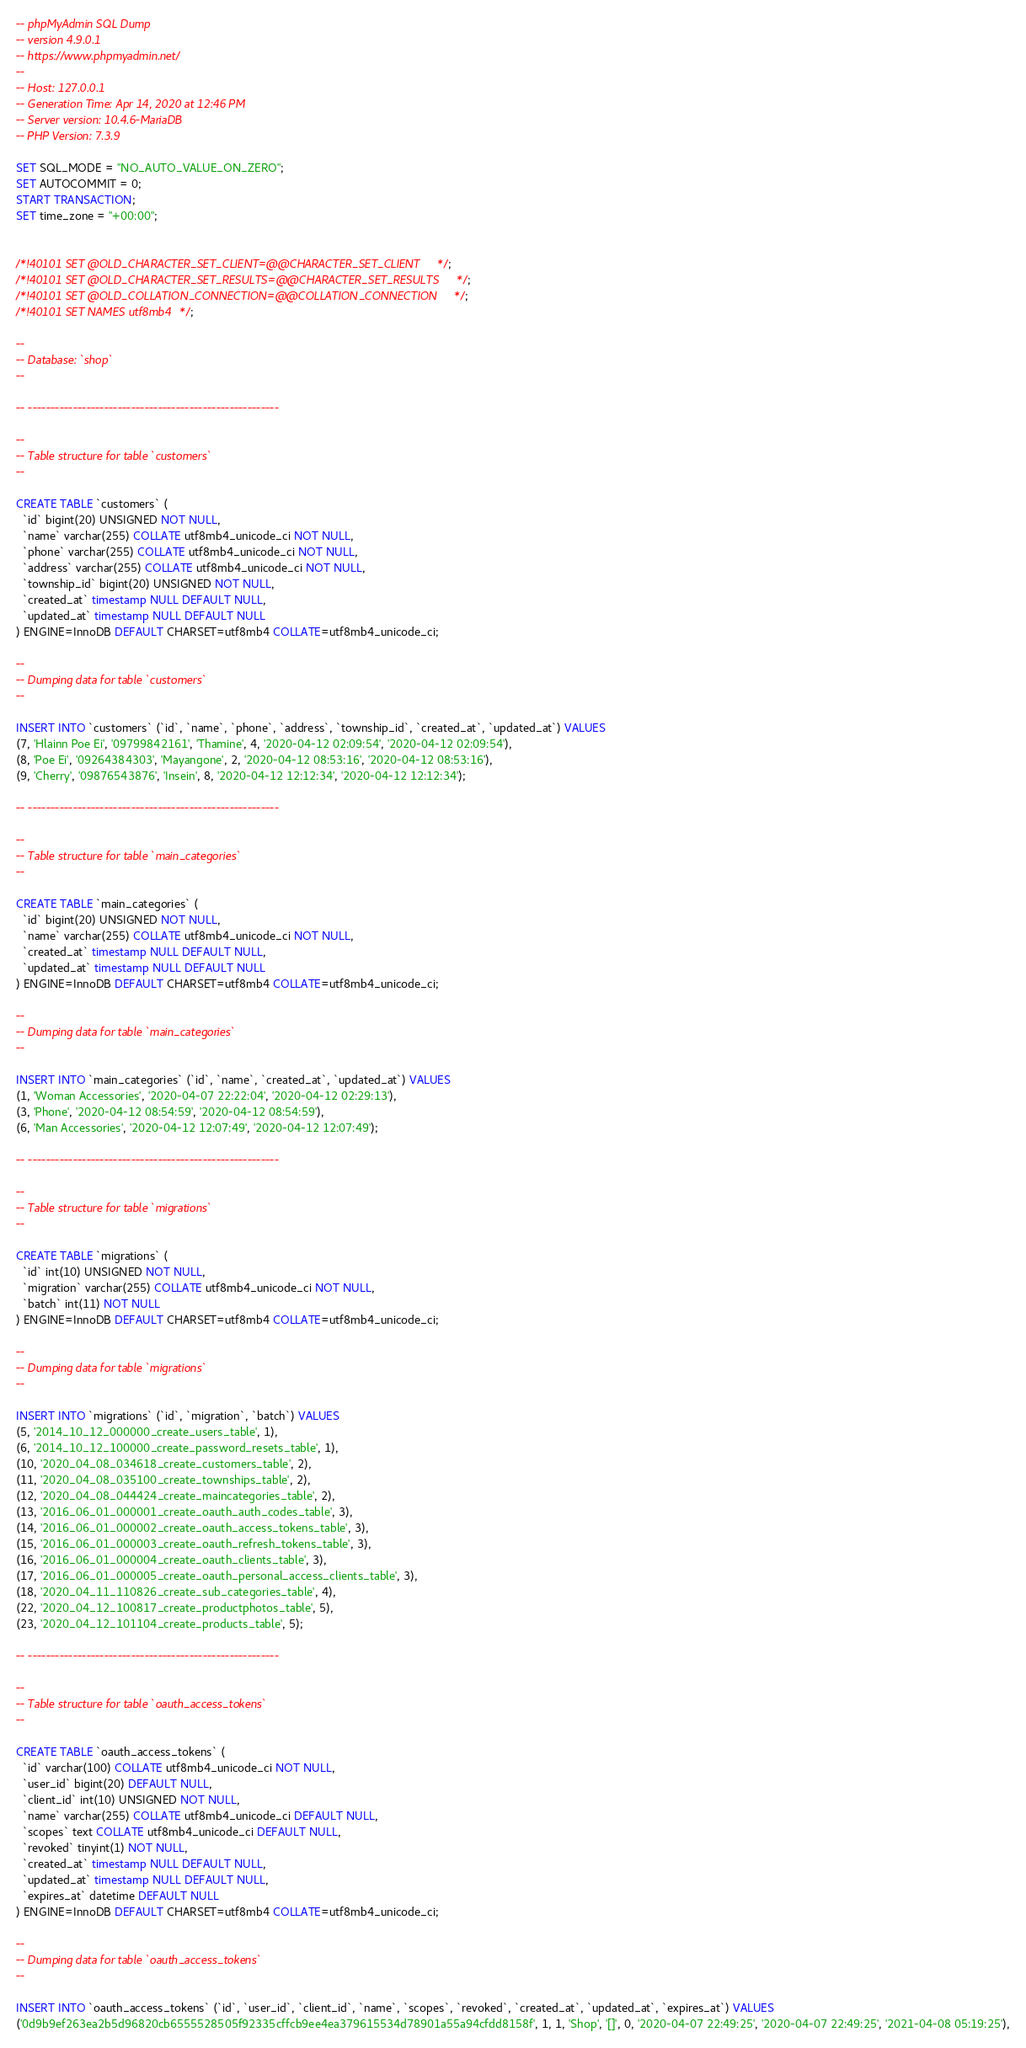<code> <loc_0><loc_0><loc_500><loc_500><_SQL_>-- phpMyAdmin SQL Dump
-- version 4.9.0.1
-- https://www.phpmyadmin.net/
--
-- Host: 127.0.0.1
-- Generation Time: Apr 14, 2020 at 12:46 PM
-- Server version: 10.4.6-MariaDB
-- PHP Version: 7.3.9

SET SQL_MODE = "NO_AUTO_VALUE_ON_ZERO";
SET AUTOCOMMIT = 0;
START TRANSACTION;
SET time_zone = "+00:00";


/*!40101 SET @OLD_CHARACTER_SET_CLIENT=@@CHARACTER_SET_CLIENT */;
/*!40101 SET @OLD_CHARACTER_SET_RESULTS=@@CHARACTER_SET_RESULTS */;
/*!40101 SET @OLD_COLLATION_CONNECTION=@@COLLATION_CONNECTION */;
/*!40101 SET NAMES utf8mb4 */;

--
-- Database: `shop`
--

-- --------------------------------------------------------

--
-- Table structure for table `customers`
--

CREATE TABLE `customers` (
  `id` bigint(20) UNSIGNED NOT NULL,
  `name` varchar(255) COLLATE utf8mb4_unicode_ci NOT NULL,
  `phone` varchar(255) COLLATE utf8mb4_unicode_ci NOT NULL,
  `address` varchar(255) COLLATE utf8mb4_unicode_ci NOT NULL,
  `township_id` bigint(20) UNSIGNED NOT NULL,
  `created_at` timestamp NULL DEFAULT NULL,
  `updated_at` timestamp NULL DEFAULT NULL
) ENGINE=InnoDB DEFAULT CHARSET=utf8mb4 COLLATE=utf8mb4_unicode_ci;

--
-- Dumping data for table `customers`
--

INSERT INTO `customers` (`id`, `name`, `phone`, `address`, `township_id`, `created_at`, `updated_at`) VALUES
(7, 'Hlainn Poe Ei', '09799842161', 'Thamine', 4, '2020-04-12 02:09:54', '2020-04-12 02:09:54'),
(8, 'Poe Ei', '09264384303', 'Mayangone', 2, '2020-04-12 08:53:16', '2020-04-12 08:53:16'),
(9, 'Cherry', '09876543876', 'Insein', 8, '2020-04-12 12:12:34', '2020-04-12 12:12:34');

-- --------------------------------------------------------

--
-- Table structure for table `main_categories`
--

CREATE TABLE `main_categories` (
  `id` bigint(20) UNSIGNED NOT NULL,
  `name` varchar(255) COLLATE utf8mb4_unicode_ci NOT NULL,
  `created_at` timestamp NULL DEFAULT NULL,
  `updated_at` timestamp NULL DEFAULT NULL
) ENGINE=InnoDB DEFAULT CHARSET=utf8mb4 COLLATE=utf8mb4_unicode_ci;

--
-- Dumping data for table `main_categories`
--

INSERT INTO `main_categories` (`id`, `name`, `created_at`, `updated_at`) VALUES
(1, 'Woman Accessories', '2020-04-07 22:22:04', '2020-04-12 02:29:13'),
(3, 'Phone', '2020-04-12 08:54:59', '2020-04-12 08:54:59'),
(6, 'Man Accessories', '2020-04-12 12:07:49', '2020-04-12 12:07:49');

-- --------------------------------------------------------

--
-- Table structure for table `migrations`
--

CREATE TABLE `migrations` (
  `id` int(10) UNSIGNED NOT NULL,
  `migration` varchar(255) COLLATE utf8mb4_unicode_ci NOT NULL,
  `batch` int(11) NOT NULL
) ENGINE=InnoDB DEFAULT CHARSET=utf8mb4 COLLATE=utf8mb4_unicode_ci;

--
-- Dumping data for table `migrations`
--

INSERT INTO `migrations` (`id`, `migration`, `batch`) VALUES
(5, '2014_10_12_000000_create_users_table', 1),
(6, '2014_10_12_100000_create_password_resets_table', 1),
(10, '2020_04_08_034618_create_customers_table', 2),
(11, '2020_04_08_035100_create_townships_table', 2),
(12, '2020_04_08_044424_create_maincategories_table', 2),
(13, '2016_06_01_000001_create_oauth_auth_codes_table', 3),
(14, '2016_06_01_000002_create_oauth_access_tokens_table', 3),
(15, '2016_06_01_000003_create_oauth_refresh_tokens_table', 3),
(16, '2016_06_01_000004_create_oauth_clients_table', 3),
(17, '2016_06_01_000005_create_oauth_personal_access_clients_table', 3),
(18, '2020_04_11_110826_create_sub_categories_table', 4),
(22, '2020_04_12_100817_create_productphotos_table', 5),
(23, '2020_04_12_101104_create_products_table', 5);

-- --------------------------------------------------------

--
-- Table structure for table `oauth_access_tokens`
--

CREATE TABLE `oauth_access_tokens` (
  `id` varchar(100) COLLATE utf8mb4_unicode_ci NOT NULL,
  `user_id` bigint(20) DEFAULT NULL,
  `client_id` int(10) UNSIGNED NOT NULL,
  `name` varchar(255) COLLATE utf8mb4_unicode_ci DEFAULT NULL,
  `scopes` text COLLATE utf8mb4_unicode_ci DEFAULT NULL,
  `revoked` tinyint(1) NOT NULL,
  `created_at` timestamp NULL DEFAULT NULL,
  `updated_at` timestamp NULL DEFAULT NULL,
  `expires_at` datetime DEFAULT NULL
) ENGINE=InnoDB DEFAULT CHARSET=utf8mb4 COLLATE=utf8mb4_unicode_ci;

--
-- Dumping data for table `oauth_access_tokens`
--

INSERT INTO `oauth_access_tokens` (`id`, `user_id`, `client_id`, `name`, `scopes`, `revoked`, `created_at`, `updated_at`, `expires_at`) VALUES
('0d9b9ef263ea2b5d96820cb6555528505f92335cffcb9ee4ea379615534d78901a55a94cfdd8158f', 1, 1, 'Shop', '[]', 0, '2020-04-07 22:49:25', '2020-04-07 22:49:25', '2021-04-08 05:19:25'),</code> 